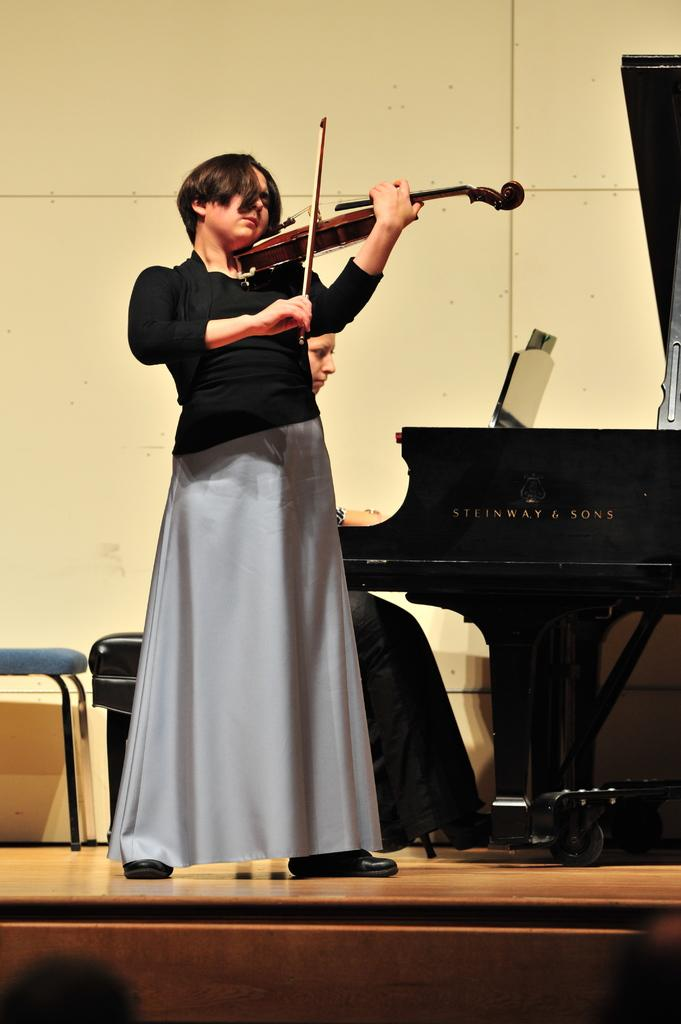Who is the main subject in the image? There is a woman in the image. What is the woman wearing? The woman is wearing a black dress. What is the woman doing in the image? The woman is playing a violin. How is the violin being held by the woman? The violin is in her hand. Are there any other people in the image? Yes, there is another person in the image. What is the other person doing? The other person is sitting and playing a piano. What type of cart can be seen carrying apples in the image? There is no cart or apples present in the image. 